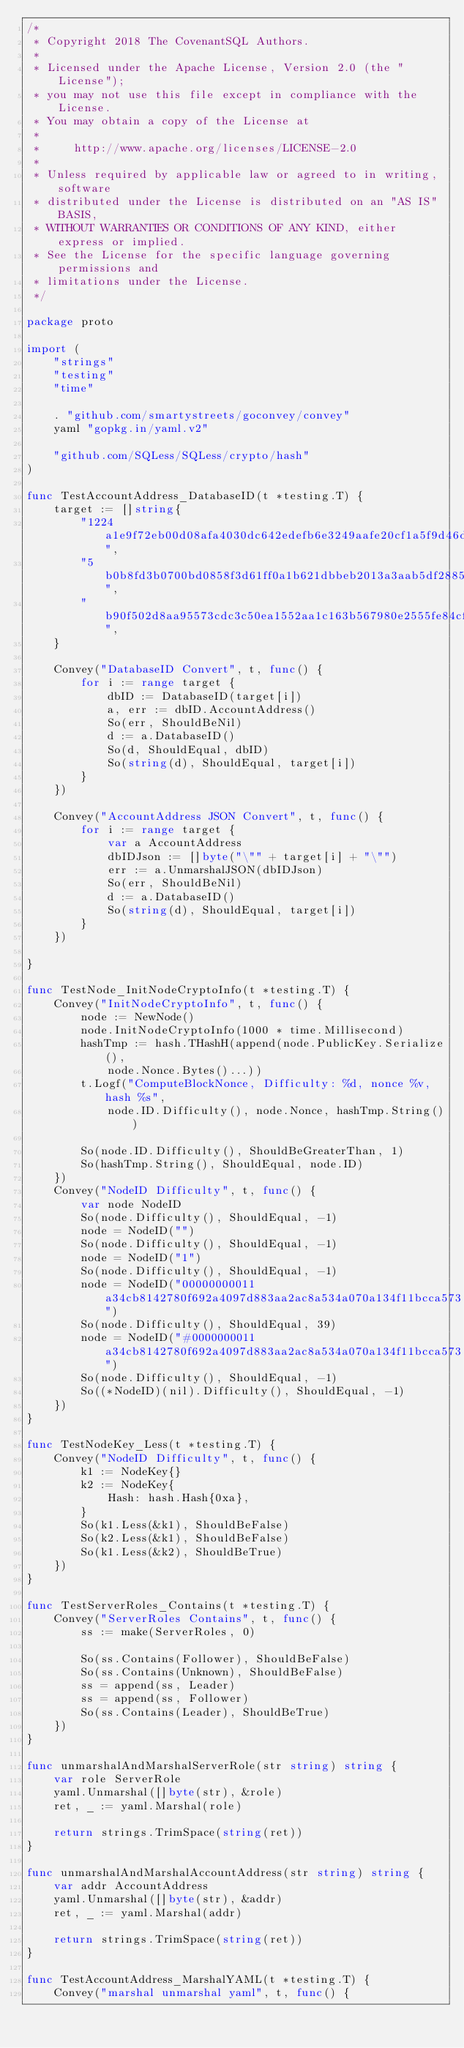Convert code to text. <code><loc_0><loc_0><loc_500><loc_500><_Go_>/*
 * Copyright 2018 The CovenantSQL Authors.
 *
 * Licensed under the Apache License, Version 2.0 (the "License");
 * you may not use this file except in compliance with the License.
 * You may obtain a copy of the License at
 *
 *     http://www.apache.org/licenses/LICENSE-2.0
 *
 * Unless required by applicable law or agreed to in writing, software
 * distributed under the License is distributed on an "AS IS" BASIS,
 * WITHOUT WARRANTIES OR CONDITIONS OF ANY KIND, either express or implied.
 * See the License for the specific language governing permissions and
 * limitations under the License.
 */

package proto

import (
	"strings"
	"testing"
	"time"

	. "github.com/smartystreets/goconvey/convey"
	yaml "gopkg.in/yaml.v2"

	"github.com/SQLess/SQLess/crypto/hash"
)

func TestAccountAddress_DatabaseID(t *testing.T) {
	target := []string{
		"1224a1e9f72eb00d08afa4030dc642edefb6e3249aafe20cf1a5f9d46d0c0bbe",
		"5b0b8fd3b0700bd0858f3d61ff0a1b621dbbeb2013a3aab5df2885dc10ccf6ce",
		"b90f502d8aa95573cdc3c50ea1552aa1c163b567980e2555fe84cfd1d5e78765",
	}

	Convey("DatabaseID Convert", t, func() {
		for i := range target {
			dbID := DatabaseID(target[i])
			a, err := dbID.AccountAddress()
			So(err, ShouldBeNil)
			d := a.DatabaseID()
			So(d, ShouldEqual, dbID)
			So(string(d), ShouldEqual, target[i])
		}
	})

	Convey("AccountAddress JSON Convert", t, func() {
		for i := range target {
			var a AccountAddress
			dbIDJson := []byte("\"" + target[i] + "\"")
			err := a.UnmarshalJSON(dbIDJson)
			So(err, ShouldBeNil)
			d := a.DatabaseID()
			So(string(d), ShouldEqual, target[i])
		}
	})

}

func TestNode_InitNodeCryptoInfo(t *testing.T) {
	Convey("InitNodeCryptoInfo", t, func() {
		node := NewNode()
		node.InitNodeCryptoInfo(1000 * time.Millisecond)
		hashTmp := hash.THashH(append(node.PublicKey.Serialize(),
			node.Nonce.Bytes()...))
		t.Logf("ComputeBlockNonce, Difficulty: %d, nonce %v, hash %s",
			node.ID.Difficulty(), node.Nonce, hashTmp.String())

		So(node.ID.Difficulty(), ShouldBeGreaterThan, 1)
		So(hashTmp.String(), ShouldEqual, node.ID)
	})
	Convey("NodeID Difficulty", t, func() {
		var node NodeID
		So(node.Difficulty(), ShouldEqual, -1)
		node = NodeID("")
		So(node.Difficulty(), ShouldEqual, -1)
		node = NodeID("1")
		So(node.Difficulty(), ShouldEqual, -1)
		node = NodeID("00000000011a34cb8142780f692a4097d883aa2ac8a534a070a134f11bcca573")
		So(node.Difficulty(), ShouldEqual, 39)
		node = NodeID("#0000000011a34cb8142780f692a4097d883aa2ac8a534a070a134f11bcca573")
		So(node.Difficulty(), ShouldEqual, -1)
		So((*NodeID)(nil).Difficulty(), ShouldEqual, -1)
	})
}

func TestNodeKey_Less(t *testing.T) {
	Convey("NodeID Difficulty", t, func() {
		k1 := NodeKey{}
		k2 := NodeKey{
			Hash: hash.Hash{0xa},
		}
		So(k1.Less(&k1), ShouldBeFalse)
		So(k2.Less(&k1), ShouldBeFalse)
		So(k1.Less(&k2), ShouldBeTrue)
	})
}

func TestServerRoles_Contains(t *testing.T) {
	Convey("ServerRoles Contains", t, func() {
		ss := make(ServerRoles, 0)

		So(ss.Contains(Follower), ShouldBeFalse)
		So(ss.Contains(Unknown), ShouldBeFalse)
		ss = append(ss, Leader)
		ss = append(ss, Follower)
		So(ss.Contains(Leader), ShouldBeTrue)
	})
}

func unmarshalAndMarshalServerRole(str string) string {
	var role ServerRole
	yaml.Unmarshal([]byte(str), &role)
	ret, _ := yaml.Marshal(role)

	return strings.TrimSpace(string(ret))
}

func unmarshalAndMarshalAccountAddress(str string) string {
	var addr AccountAddress
	yaml.Unmarshal([]byte(str), &addr)
	ret, _ := yaml.Marshal(addr)

	return strings.TrimSpace(string(ret))
}

func TestAccountAddress_MarshalYAML(t *testing.T) {
	Convey("marshal unmarshal yaml", t, func() {</code> 